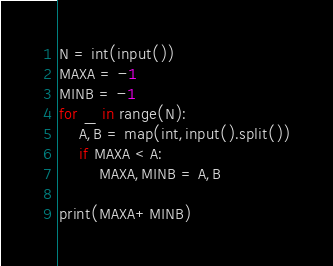Convert code to text. <code><loc_0><loc_0><loc_500><loc_500><_Python_>N = int(input())
MAXA = -1
MINB = -1
for _ in range(N):
    A,B = map(int,input().split())
    if MAXA < A:
        MAXA,MINB = A,B
    
print(MAXA+MINB)</code> 